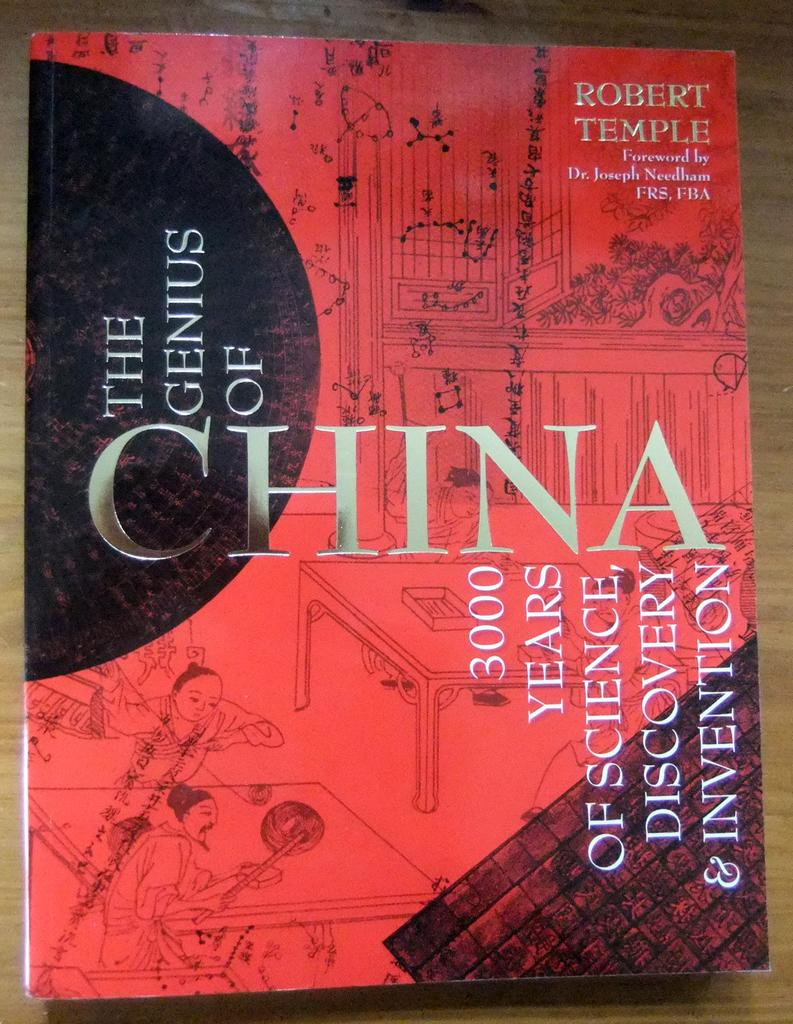<image>
Describe the image concisely. A copy of the book The Genius of China by Robert Temple. 